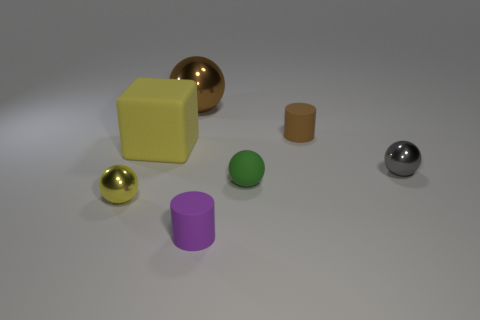Subtract all big brown spheres. How many spheres are left? 3 Add 1 brown matte cylinders. How many objects exist? 8 Subtract all brown balls. How many balls are left? 3 Subtract all cylinders. How many objects are left? 5 Subtract all yellow balls. Subtract all big brown shiny spheres. How many objects are left? 5 Add 3 yellow matte blocks. How many yellow matte blocks are left? 4 Add 7 big gray shiny cubes. How many big gray shiny cubes exist? 7 Subtract 1 green spheres. How many objects are left? 6 Subtract all cyan cylinders. Subtract all purple blocks. How many cylinders are left? 2 